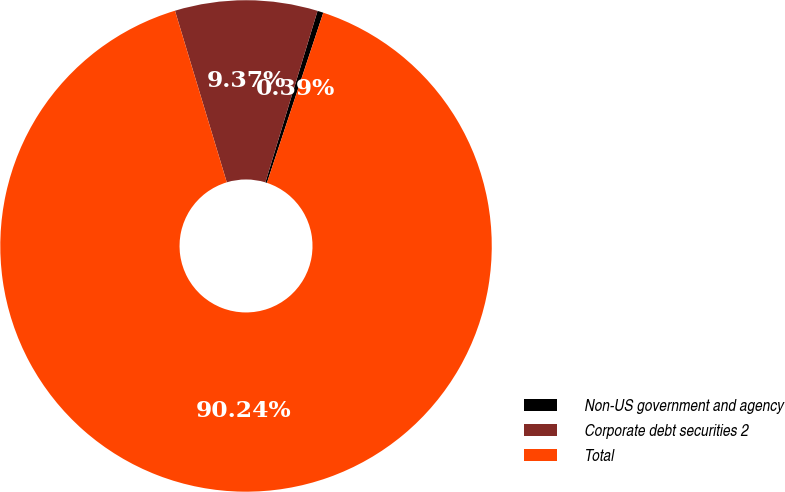Convert chart. <chart><loc_0><loc_0><loc_500><loc_500><pie_chart><fcel>Non-US government and agency<fcel>Corporate debt securities 2<fcel>Total<nl><fcel>0.39%<fcel>9.37%<fcel>90.24%<nl></chart> 